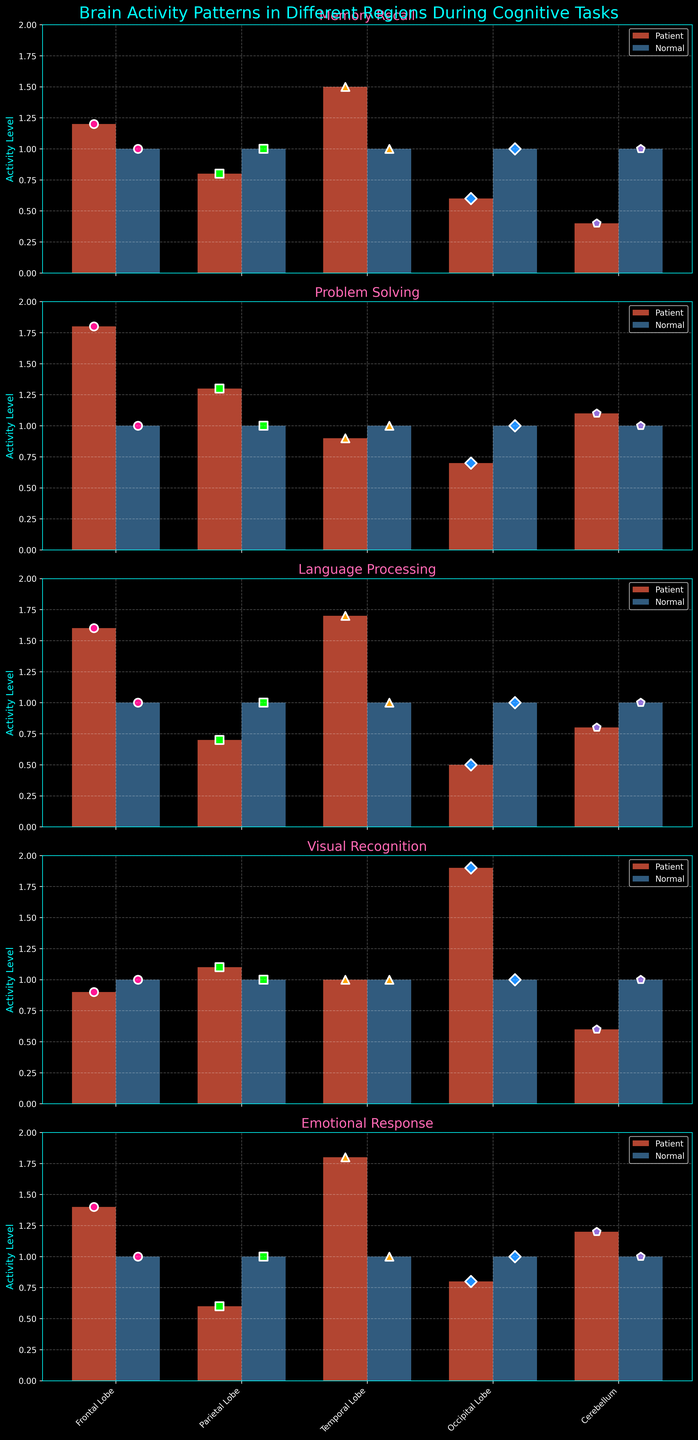Which region shows the greatest difference in activity level between the patient and normal subjects during Memory Recall? To find the greatest difference, look at the bars for Memory Recall across each region. The biggest difference visually is between the Temporal Lobe where the patient’s activity level (1.5) is higher than the normal subject’s (1.0). The difference is 0.5. This is greater than the differences in the other regions.
Answer: Temporal Lobe In the Frontal Lobe, during which cognitive task does the patient exhibit less activity compared to normal subjects? Examine the patient and normal bars for the Frontal Lobe in each subplot. For Visual Recognition, the patient's activity level (0.9) is less than the normal subject's (1.0).
Answer: Visual Recognition Which cognitive task shows the smallest deviation in the Occipital Lobe activity for the patient when compared to normal subjects? Locate the Occipital Lobe bars across all tasks and compare the deviations. For Problem Solving, the patient’s activity level (0.7) is close to the normal subject’s (1.0) with a deviation of 0.3, which is the smallest among all tasks.
Answer: Problem Solving On average, is the patient’s brain activity in the Temporal Lobe higher or lower across all tasks compared to normal subjects? To obtain the average, calculate the sum of the patient’s values for the Temporal Lobe (1.5, 0.9, 1.7, 1.0, 1.8) and the normal subject’s values (1.0, 1.0, 1.0, 1.0, 1.0). The sum for the patient is 6.9, and for the normal subject is 5.0. The average for the patient is 6.9/5 = 1.38 and for normal subjects is 5.0/5 = 1.0. Therefore, the patient’s average activity is higher.
Answer: Higher Which cognitive task shows a complete match in activity level between the patient and normal subjects in the Parietal Lobe? Inspect the Parietal Lobe bars for all tasks. Only the Visual Recognition task shows equal bars (both at 1.1).
Answer: Visual Recognition Compare the activity level in the Cerebellum of the patient and normal subjects during Emotional Response. How much higher or lower is it? The patient’s activity level in the Cerebellum during Emotional Response is 1.2 while the normal subject’s is 1.0. The patient’s activity is higher by 0.2.
Answer: 0.2 higher Find the task in which the patient displays the highest activity in the Frontal Lobe. Check the Frontal Lobe bars across tasks. The highest activity level for the patient in the Frontal Lobe is during Problem Solving (1.8).
Answer: Problem Solving Which brain region for the patient exhibits the lowest activity level during the Language Processing task? For Language Processing, compare the patient's activity levels across regions. The Occipital Lobe has the lowest activity level at 0.5.
Answer: Occipital Lobe 